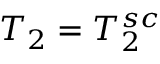<formula> <loc_0><loc_0><loc_500><loc_500>T _ { 2 } = T _ { 2 } ^ { s c }</formula> 